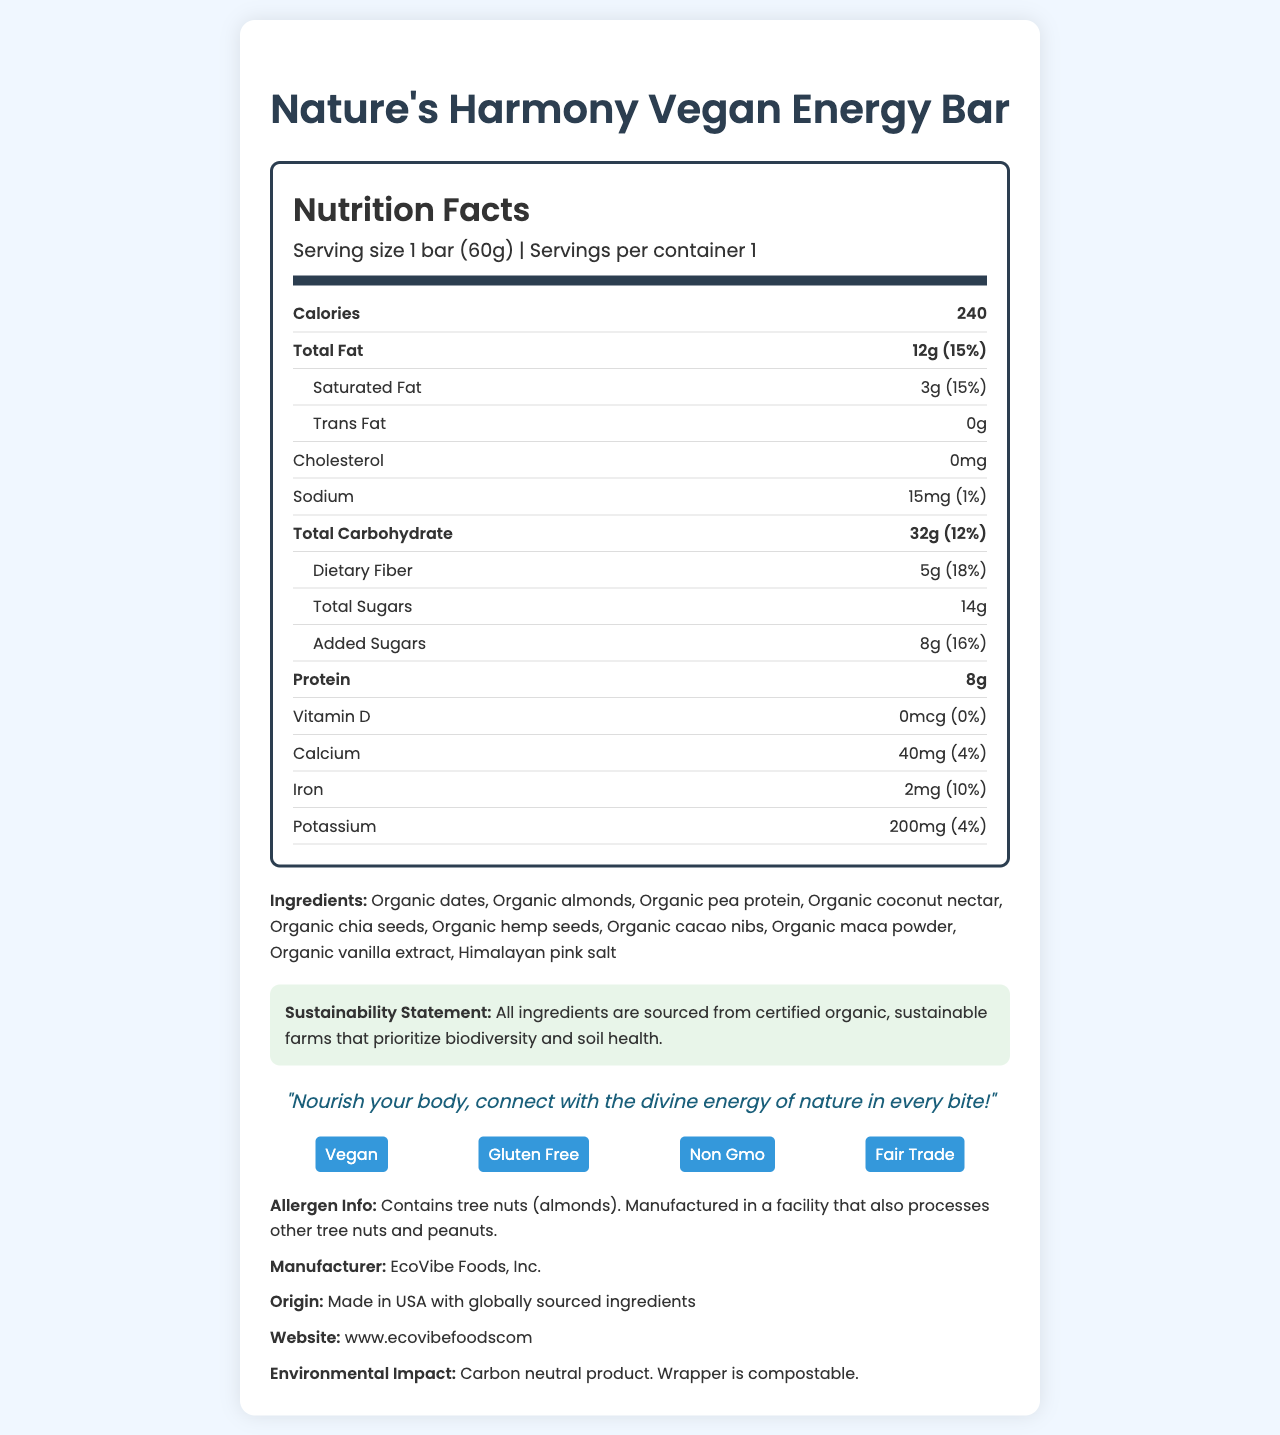How many calories are in one serving of the Nature's Harmony Vegan Energy Bar? The document lists the calories as 240 under the nutrition section for one serving.
Answer: 240 calories What is the serving size of the Nature's Harmony Vegan Energy Bar? The serving size is specified as "1 bar (60g)" in the document.
Answer: 1 bar (60g) Which ingredient in the Nature's Harmony Vegan Energy Bar is a source of tree nuts? The ingredient section lists "Organic almonds," which are tree nuts.
Answer: Organic almonds Does the Nature's Harmony Vegan Energy Bar contain any trans fat? The nutrition label states that there are 0g of trans fat.
Answer: No How much protein is in one serving of this energy bar? The nutrition section shows that there are 8g of protein per serving.
Answer: 8g What percentage of the daily value for dietary fiber does the Nature's Harmony Vegan Energy Bar provide? The nutrition label indicates that the dietary fiber content is 5g, which is 18% of the daily value.
Answer: 18% Where are the ingredients of this energy bar sourced from? The sustainability statement mentions that all ingredients are sourced from certified organic, sustainable farms.
Answer: Certified organic, sustainable farms How much iron does this energy bar provide per serving? A. 1mg B. 2mg C. 3mg D. 4mg The nutrition section lists 2mg of iron per serving.
Answer: B. 2mg What is the sodium content per serving of this energy bar? A. 10mg B. 15mg C. 20mg D. 25mg The nutrition section indicates there are 15mg of sodium per serving.
Answer: B. 15mg Is the Nature's Harmony Vegan Energy Bar gluten-free? The additional info section specifies that the product is gluten-free.
Answer: Yes Summarize the main idea of the document. The document details the nutrition facts, ingredients, allergen info, sustainability statement, additional product features, manufacturer, and environmental impact of the "Nature's Harmony Vegan Energy Bar."
Answer: The document provides detailed nutrition facts for the "Nature's Harmony Vegan Energy Bar," highlighting its organic and sustainable ingredients, nutritional content, allergen information, and environmental impact. The bar is vegan, gluten-free, non-GMO, and fair trade. What is the manufacturer's name? The document mentions the manufacturer as "EcoVibe Foods, Inc."
Answer: EcoVibe Foods, Inc. Does the energy bar contain any added sugars? The nutrition section shows "Added Sugars" with an amount of 8g.
Answer: Yes What is the daily value percentage of calcium provided by this energy bar? The nutrition label indicates that the calcium content is 40mg, which is 4% of the daily value.
Answer: 4% Where is this product made? The origin section specifies "Made in USA with globally sourced ingredients."
Answer: Made in USA with globally sourced ingredients How much Vitamin D does the Nature's Harmony Vegan Energy Bar contain? The nutrition label lists the Vitamin D content as 0mcg.
Answer: 0mcg What sustainability practices does EcoVibe Foods, Inc. follow for this product? The document mentions ingredients are sourced from sustainable farms and states a carbon neutral product with compostable wrappers, but doesn't detail specific sustainability practices.
Answer: Cannot be determined What is the product's pantheistic slogan? The slogan section of the document states this exact phrase.
Answer: Nourish your body, connect with the divine energy of nature in every bite! 